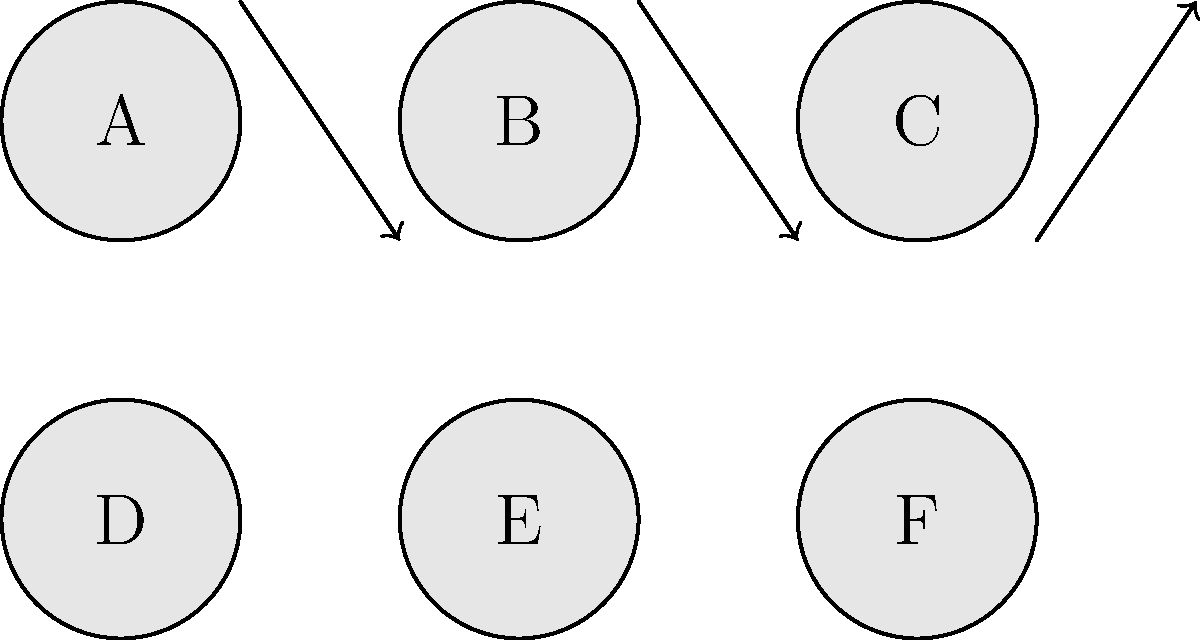In a surreal cityscape, six otherworldly elements (A, B, C, D, E, F) are arranged in a 2x3 grid. A permutation $\sigma$ rearranges these elements as shown by the arrows in the diagram. Express $\sigma$ in cycle notation and determine its order in the permutation group $S_6$. To solve this problem, let's follow these steps:

1. Identify the cycles in the permutation:
   - A moves to D
   - B moves to E
   - C moves to F
   - D stays in place
   - E stays in place
   - F moves to C

2. Express $\sigma$ in cycle notation:
   $\sigma = (AD)(BE)(CF)$

3. Determine the order of $\sigma$:
   - The order of a permutation is the least common multiple (LCM) of the lengths of its disjoint cycles.
   - Each cycle (AD), (BE), and (CF) has length 2.
   - LCM(2, 2, 2) = 2

4. Therefore, the order of $\sigma$ in $S_6$ is 2.

This means that applying $\sigma$ twice will return the elements to their original positions, reflecting the dreamlike, cyclical nature of the surreal cityscape.
Answer: $\sigma = (AD)(BE)(CF)$, order = 2 